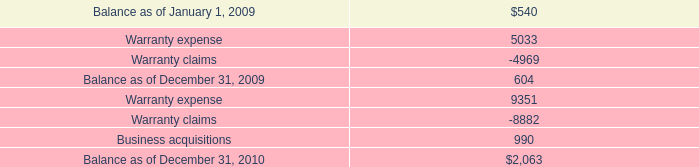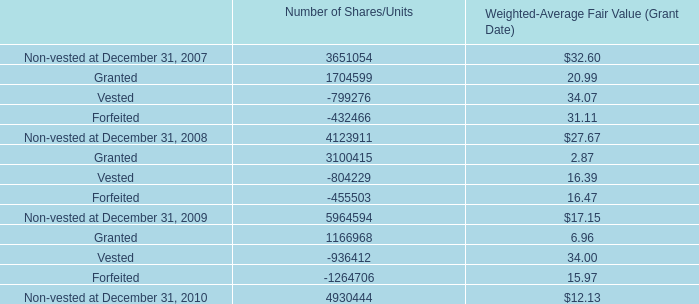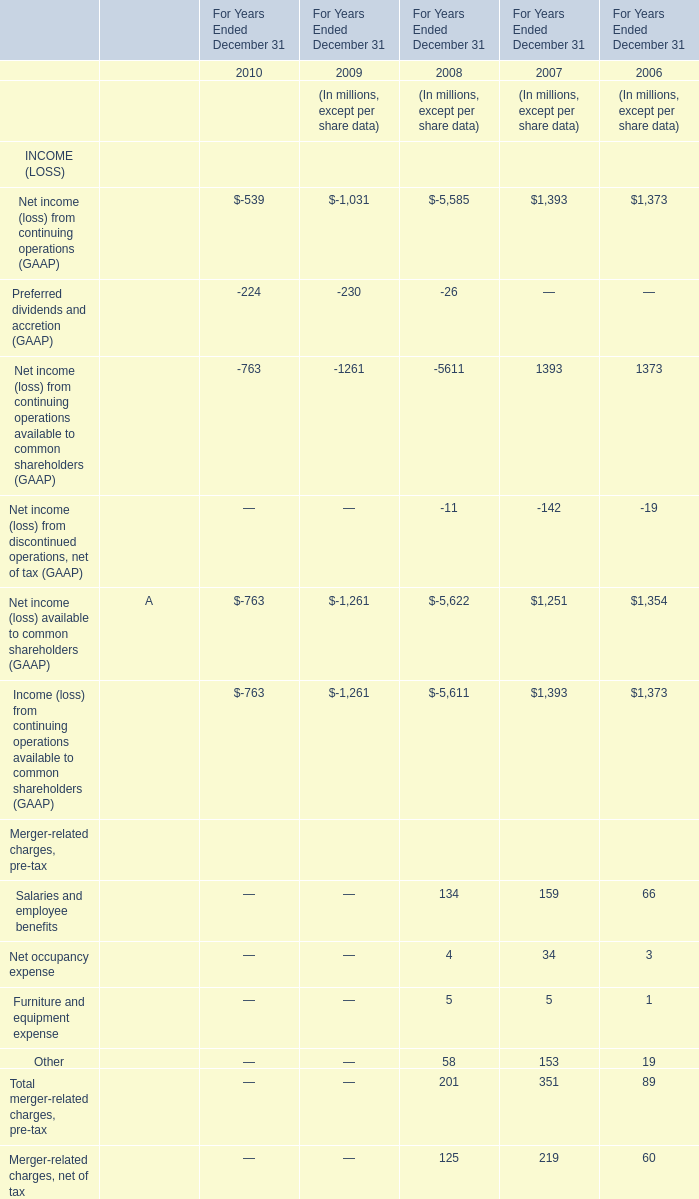at december 31 , 2009 what was the difference between the fair value of our term loans to their carrying value in millions 
Computations: (596 - 570)
Answer: 26.0. 